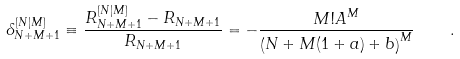Convert formula to latex. <formula><loc_0><loc_0><loc_500><loc_500>\delta _ { N + M + 1 } ^ { [ N | M ] } \equiv \frac { R _ { N + M + 1 } ^ { [ N | M ] } - R _ { N + M + 1 } } { R _ { N + M + 1 } } = - \frac { M ! A ^ { M } } { \left ( N + M ( 1 + a ) + b \right ) ^ { M } } \quad .</formula> 